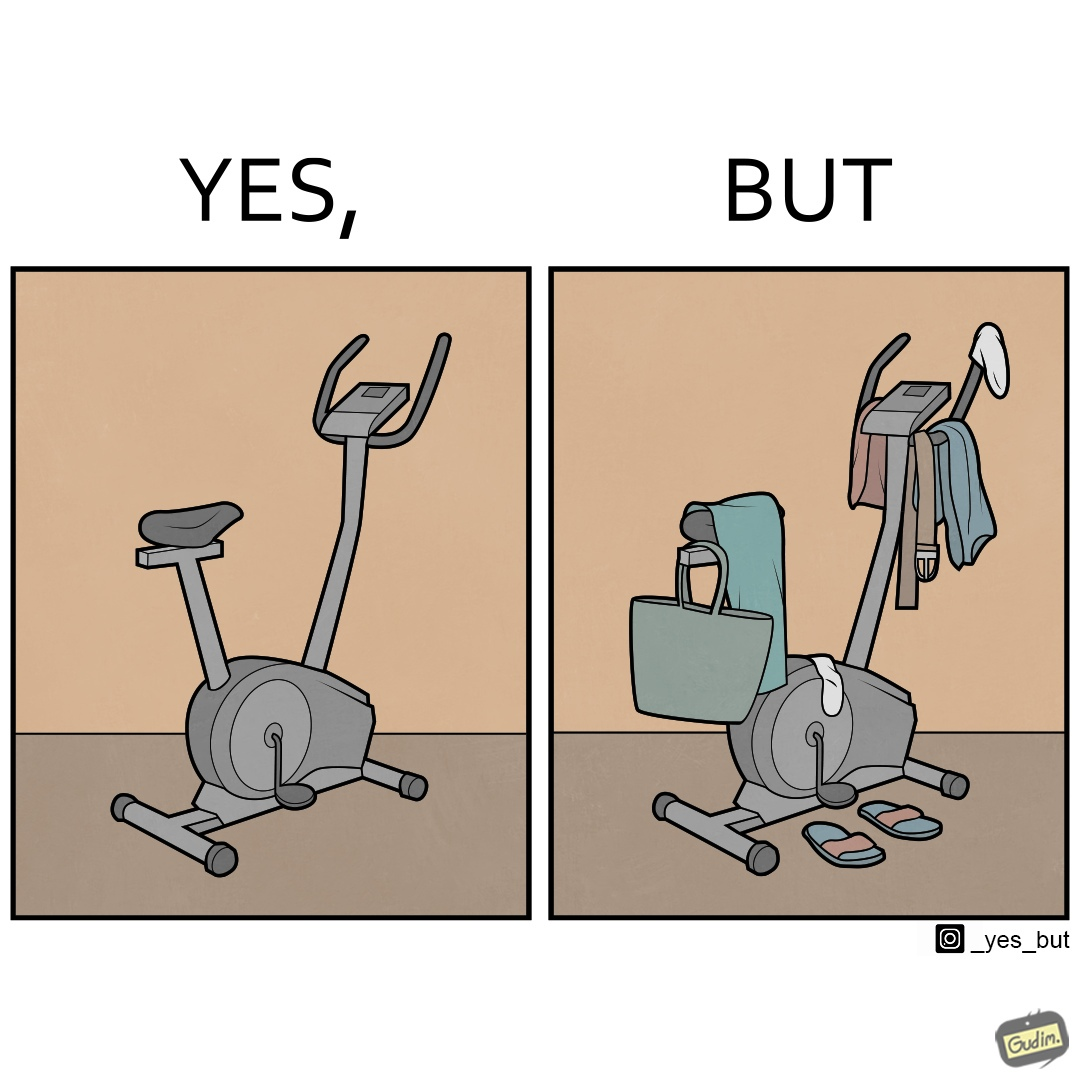Describe what you see in the left and right parts of this image. In the left part of the image: An exercise bike In the right part of the image: An exercise bike being used to hang clothes and other items 